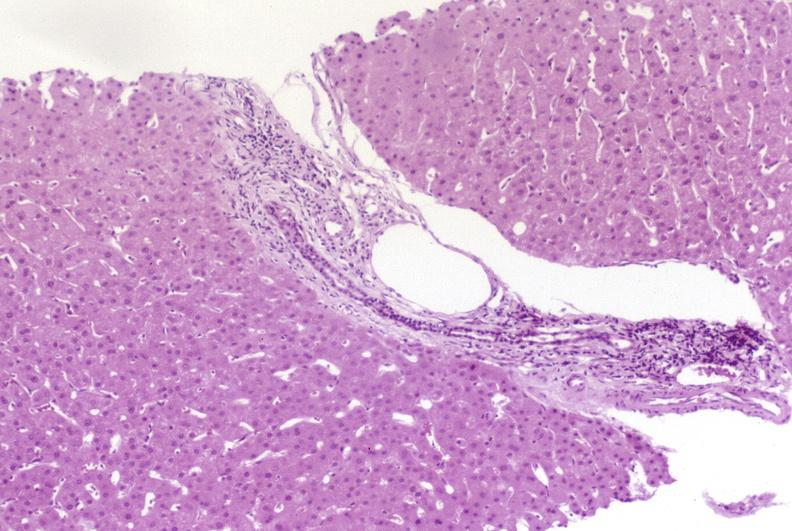s traumatic rupture present?
Answer the question using a single word or phrase. No 